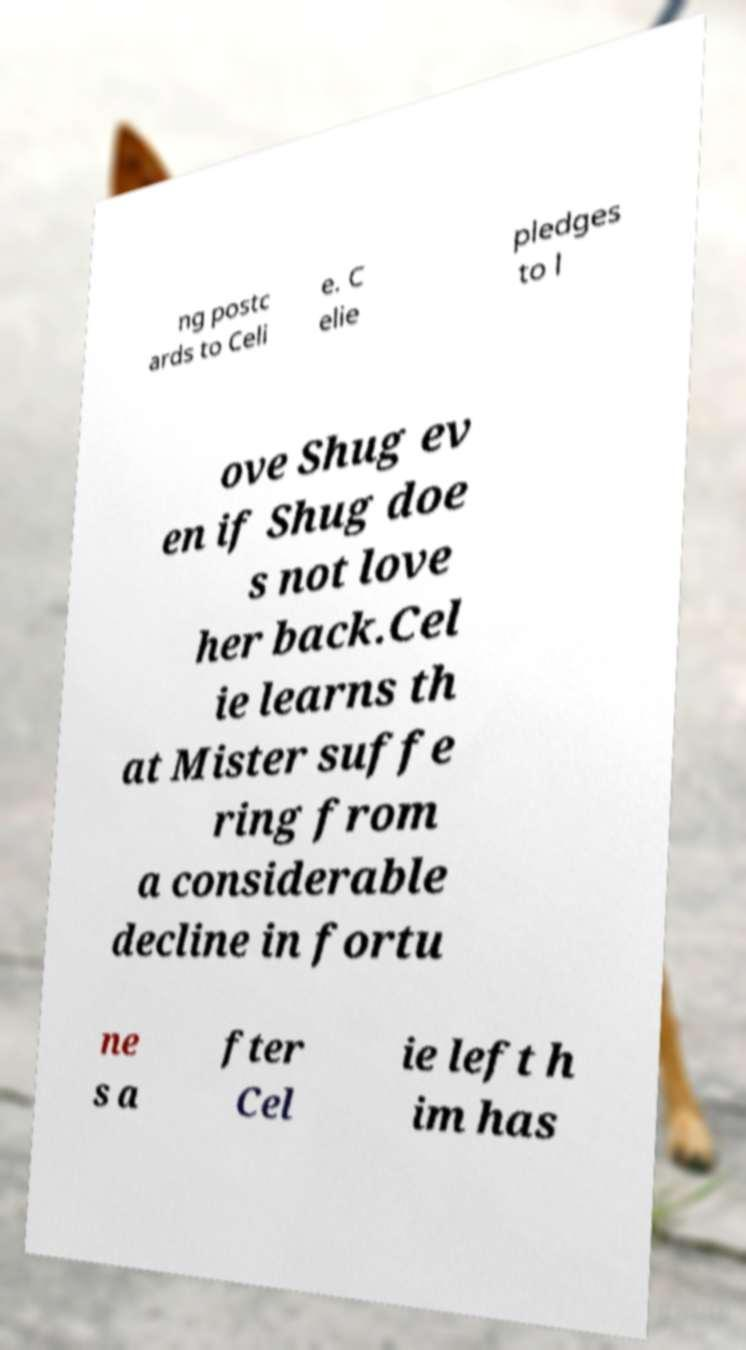What messages or text are displayed in this image? I need them in a readable, typed format. ng postc ards to Celi e. C elie pledges to l ove Shug ev en if Shug doe s not love her back.Cel ie learns th at Mister suffe ring from a considerable decline in fortu ne s a fter Cel ie left h im has 